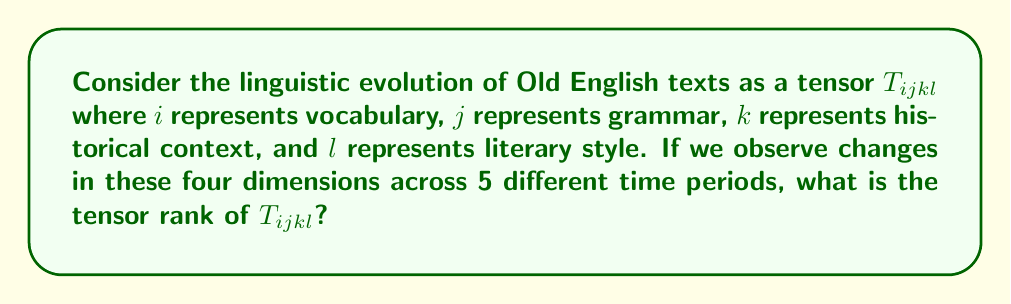What is the answer to this math problem? To determine the tensor rank of $T_{ijkl}$, we need to follow these steps:

1. Understand the dimensions:
   - $i$: vocabulary (5 time periods)
   - $j$: grammar (5 time periods)
   - $k$: historical context (5 time periods)
   - $l$: literary style (5 time periods)

2. Determine the shape of the tensor:
   The tensor $T_{ijkl}$ has shape (5, 5, 5, 5) as each dimension has 5 components.

3. Calculate the tensor rank:
   The tensor rank is the number of indices needed to represent the tensor. In this case, we have four indices $(i, j, k, l)$, each representing a different aspect of linguistic evolution.

4. Consider the significance:
   This 4th-order tensor captures the complex interactions between vocabulary, grammar, historical context, and literary style across different time periods in Old English texts.

5. Historical interpretation:
   For a history major, this tensor representation allows for a multidimensional analysis of how historical events influenced the evolution of Old English literature across these four aspects simultaneously.

Therefore, the tensor rank of $T_{ijkl}$ is 4, as it requires four indices to fully describe the linguistic evolution in Old English texts across the specified dimensions.
Answer: 4 